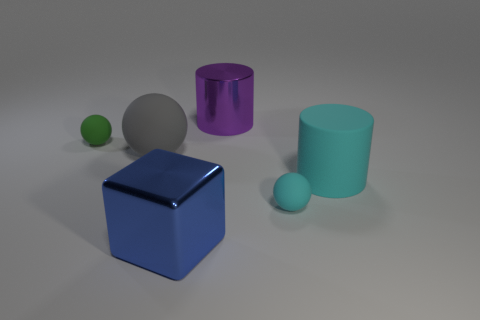Is there a matte thing that has the same color as the rubber cylinder?
Offer a very short reply. Yes. There is a big cylinder that is right of the cyan sphere; what number of blue objects are behind it?
Make the answer very short. 0. Are there more big cyan things than brown rubber objects?
Make the answer very short. Yes. Does the cyan cylinder have the same material as the blue cube?
Offer a terse response. No. Are there the same number of large gray objects that are behind the tiny green object and metal things?
Give a very brief answer. No. What number of other cylinders are made of the same material as the large cyan cylinder?
Make the answer very short. 0. Is the number of small cyan matte objects less than the number of green matte cubes?
Offer a terse response. No. There is a small sphere that is behind the small cyan sphere; is it the same color as the big rubber sphere?
Your response must be concise. No. How many cyan cylinders are behind the cylinder to the left of the large rubber thing that is on the right side of the large purple shiny thing?
Provide a short and direct response. 0. What number of cyan rubber cylinders are to the right of the large gray ball?
Provide a succinct answer. 1. 